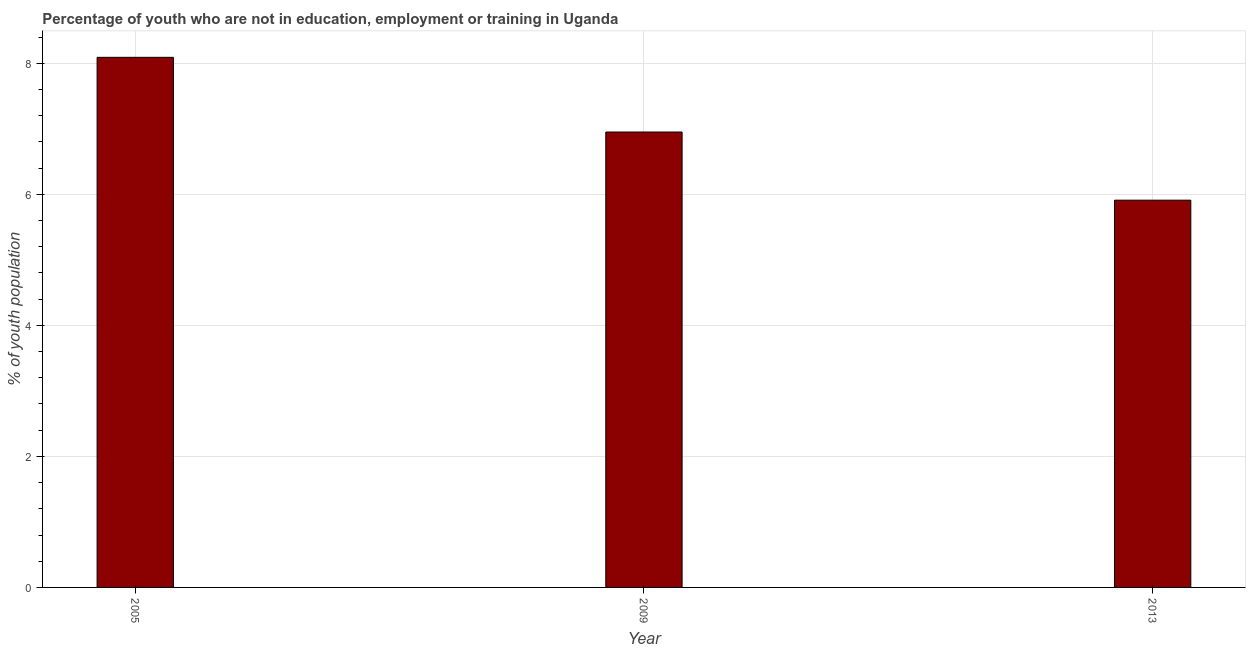Does the graph contain grids?
Keep it short and to the point. Yes. What is the title of the graph?
Offer a very short reply. Percentage of youth who are not in education, employment or training in Uganda. What is the label or title of the X-axis?
Provide a succinct answer. Year. What is the label or title of the Y-axis?
Provide a succinct answer. % of youth population. What is the unemployed youth population in 2005?
Your response must be concise. 8.09. Across all years, what is the maximum unemployed youth population?
Offer a terse response. 8.09. Across all years, what is the minimum unemployed youth population?
Make the answer very short. 5.91. What is the sum of the unemployed youth population?
Ensure brevity in your answer.  20.95. What is the difference between the unemployed youth population in 2005 and 2009?
Ensure brevity in your answer.  1.14. What is the average unemployed youth population per year?
Make the answer very short. 6.98. What is the median unemployed youth population?
Offer a terse response. 6.95. In how many years, is the unemployed youth population greater than 2 %?
Offer a terse response. 3. What is the ratio of the unemployed youth population in 2005 to that in 2013?
Keep it short and to the point. 1.37. Is the unemployed youth population in 2009 less than that in 2013?
Ensure brevity in your answer.  No. Is the difference between the unemployed youth population in 2009 and 2013 greater than the difference between any two years?
Offer a terse response. No. What is the difference between the highest and the second highest unemployed youth population?
Your answer should be very brief. 1.14. What is the difference between the highest and the lowest unemployed youth population?
Provide a succinct answer. 2.18. What is the difference between two consecutive major ticks on the Y-axis?
Keep it short and to the point. 2. What is the % of youth population of 2005?
Your answer should be very brief. 8.09. What is the % of youth population of 2009?
Offer a very short reply. 6.95. What is the % of youth population in 2013?
Offer a very short reply. 5.91. What is the difference between the % of youth population in 2005 and 2009?
Offer a very short reply. 1.14. What is the difference between the % of youth population in 2005 and 2013?
Your answer should be very brief. 2.18. What is the difference between the % of youth population in 2009 and 2013?
Offer a terse response. 1.04. What is the ratio of the % of youth population in 2005 to that in 2009?
Make the answer very short. 1.16. What is the ratio of the % of youth population in 2005 to that in 2013?
Ensure brevity in your answer.  1.37. What is the ratio of the % of youth population in 2009 to that in 2013?
Keep it short and to the point. 1.18. 